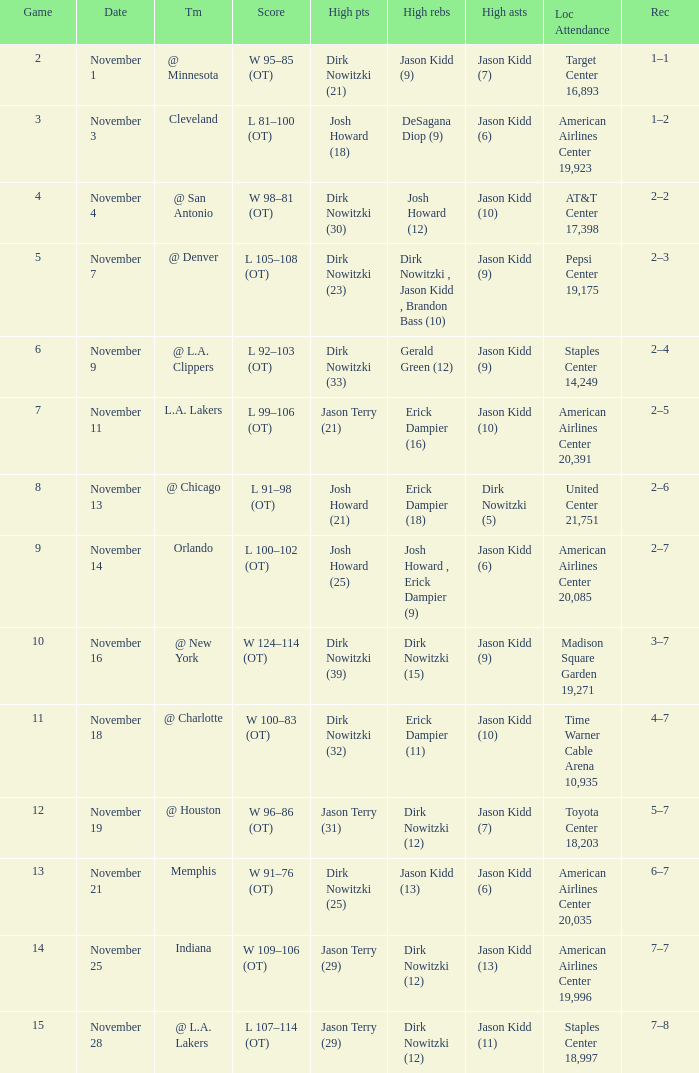What was the record on November 1? 1–1. 